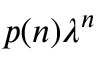Convert formula to latex. <formula><loc_0><loc_0><loc_500><loc_500>p ( n ) \lambda ^ { n }</formula> 